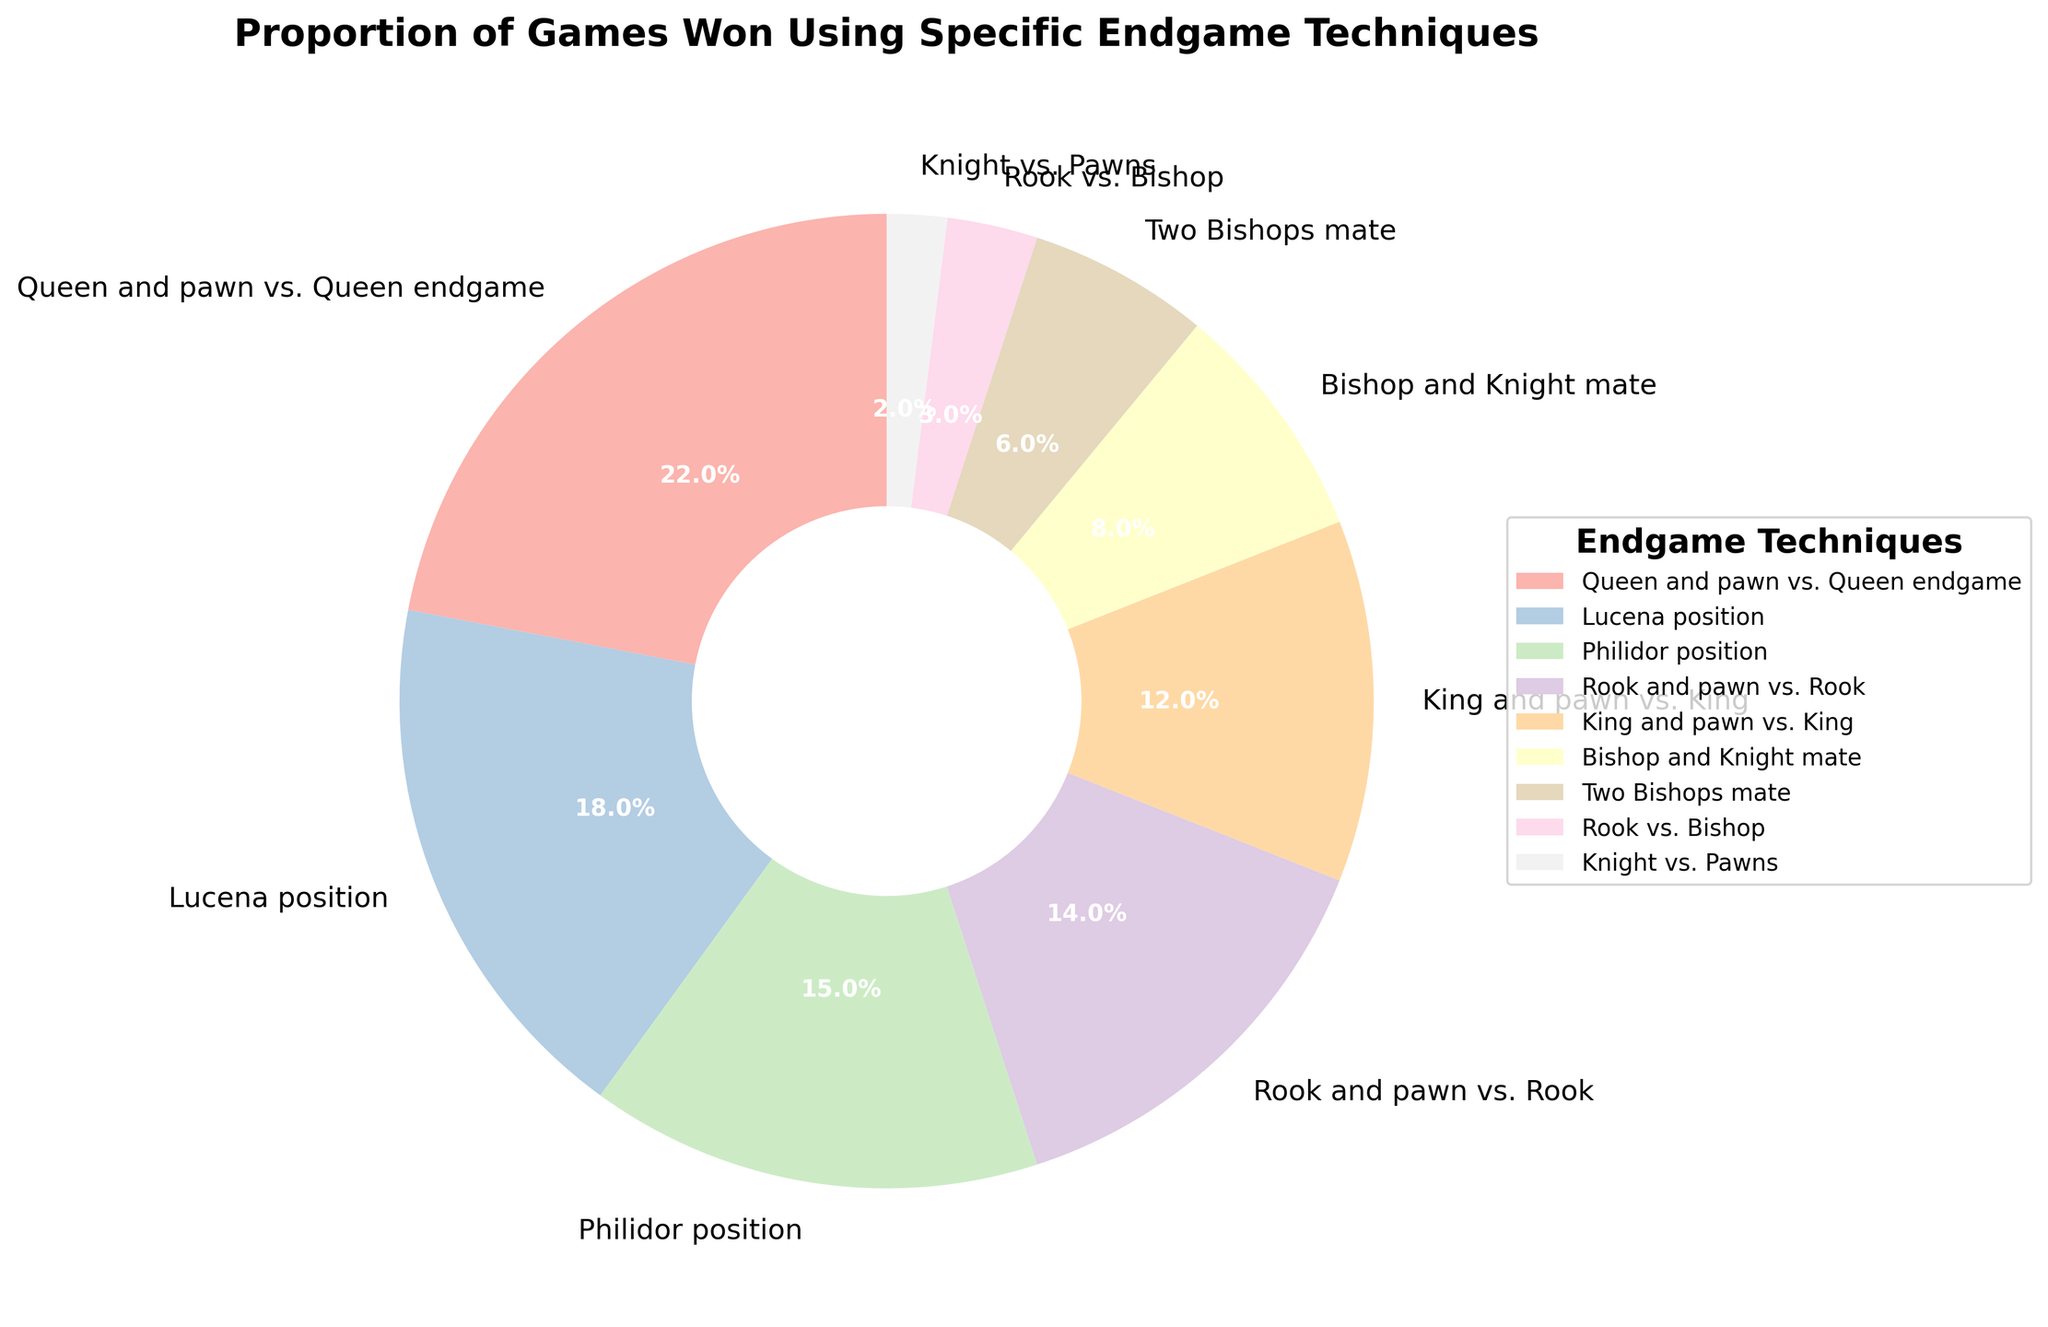What is the most commonly used endgame technique? The segment representing "Queen and pawn vs. Queen endgame" has the largest proportion (22%), which indicates it is the most commonly used endgame technique.
Answer: Queen and pawn vs. Queen endgame Which endgame technique has the smallest proportion of games won? The smallest segment belongs to "Knight vs. Pawns" with a proportion of 2%.
Answer: Knight vs. Pawns How many endgame techniques have a proportion of 10% or more? By observing the chart, "Queen and pawn vs. Queen endgame" (22%), "Lucena position" (18%), "Philidor position" (15%), "Rook and pawn vs. Rook" (14%), and "King and pawn vs. King" (12%) have proportions of 10% or more. There are 5 techniques.
Answer: 5 What is the combined proportion of "Lucena position" and "Philidor position"? "Lucena position" has a proportion of 18%, and "Philidor position" has a proportion of 15%. Adding these together results in 18% + 15% = 33%.
Answer: 33% Which endgame technique has a larger proportion, "Rook vs. Bishop" or "Bishop and Knight mate"? The "Bishop and Knight mate" has a larger proportion at 8%, compared to "Rook vs. Bishop" which has 3%.
Answer: Bishop and Knight mate What's the difference in proportion between "King and pawn vs. King" and "Rook and pawn vs. Rook"? "Rook and pawn vs. Rook" has a proportion of 14% while "King and pawn vs. King" has 12%. The difference is 14% - 12% = 2%.
Answer: 2% What is the total proportion of games won by techniques involving pawns (Queen and pawn vs. Queen endgame, Rook and pawn vs. Rook, King and pawn vs. King, Knight vs. Pawns)? Summing the proportions of "Queen and pawn vs. Queen endgame" (22%), "Rook and pawn vs. Rook" (14%), "King and pawn vs. King" (12%), and "Knight vs. Pawns" (2%) results in 22% + 14% + 12% + 2% = 50%.
Answer: 50% Which color represents the "Two Bishops mate" technique? The color representing "Two Bishops mate" can be identified as a pastel color (specific color names were not given, but based on context it is one of the shades of the Pastel1 color scheme). A close inspection of the chart reveals this segment.
Answer: Pastel color (specific shade as per Pastel1 scheme) 